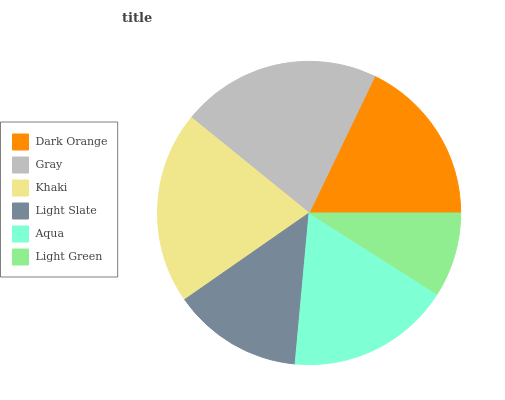Is Light Green the minimum?
Answer yes or no. Yes. Is Gray the maximum?
Answer yes or no. Yes. Is Khaki the minimum?
Answer yes or no. No. Is Khaki the maximum?
Answer yes or no. No. Is Gray greater than Khaki?
Answer yes or no. Yes. Is Khaki less than Gray?
Answer yes or no. Yes. Is Khaki greater than Gray?
Answer yes or no. No. Is Gray less than Khaki?
Answer yes or no. No. Is Dark Orange the high median?
Answer yes or no. Yes. Is Aqua the low median?
Answer yes or no. Yes. Is Gray the high median?
Answer yes or no. No. Is Dark Orange the low median?
Answer yes or no. No. 